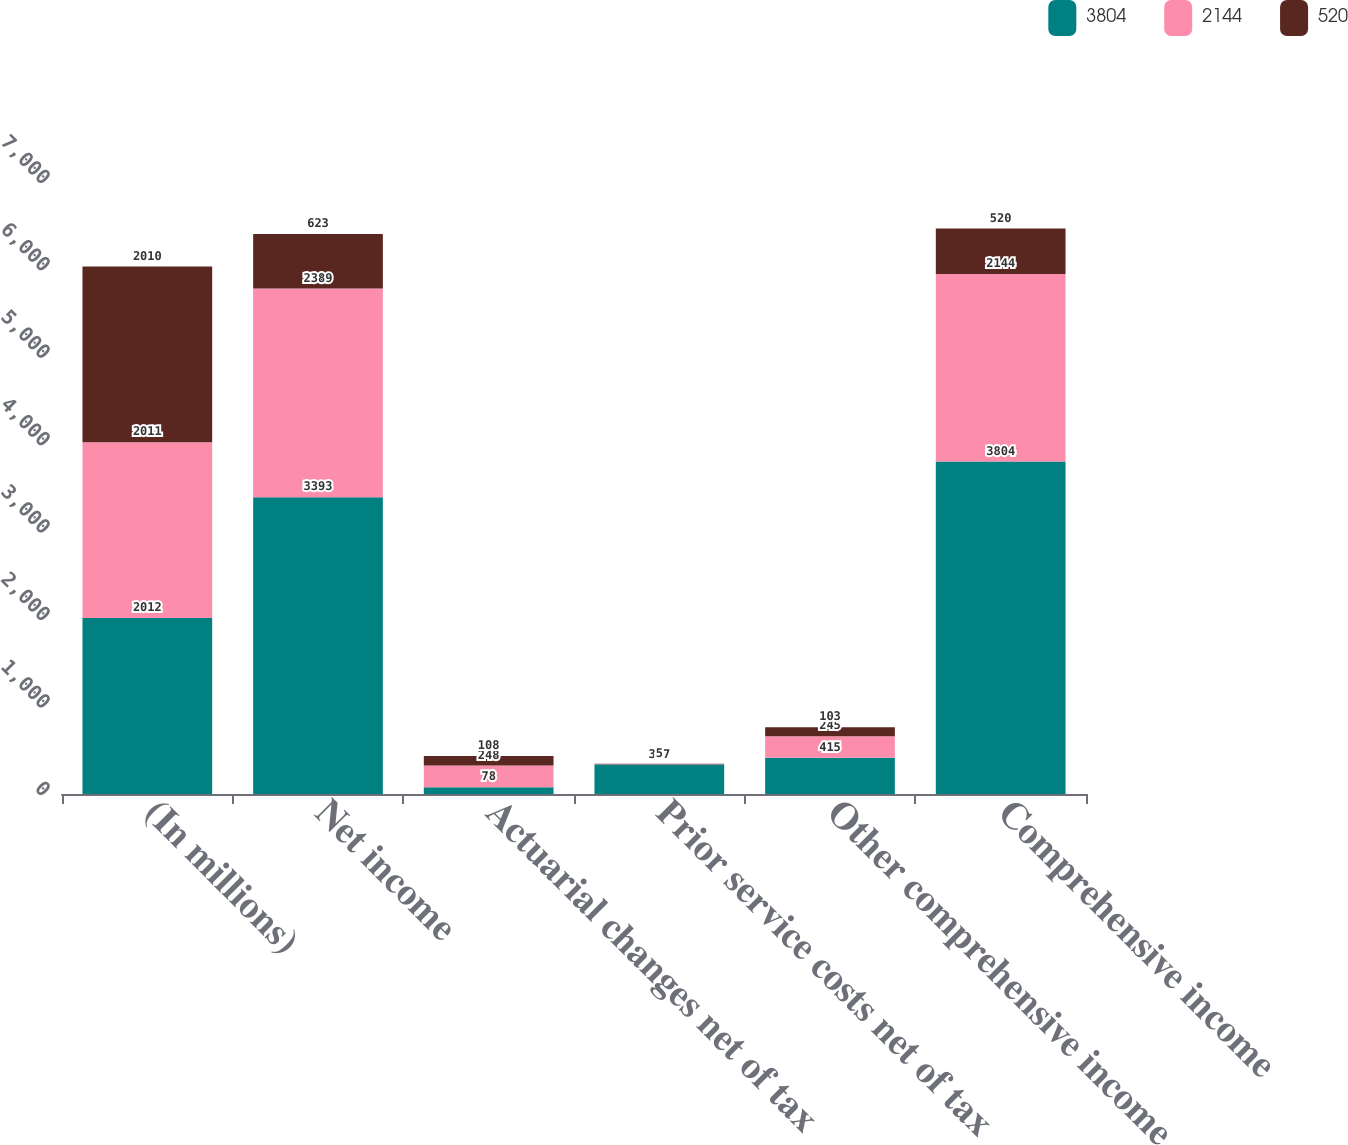Convert chart to OTSL. <chart><loc_0><loc_0><loc_500><loc_500><stacked_bar_chart><ecel><fcel>(In millions)<fcel>Net income<fcel>Actuarial changes net of tax<fcel>Prior service costs net of tax<fcel>Other comprehensive income<fcel>Comprehensive income<nl><fcel>3804<fcel>2012<fcel>3393<fcel>78<fcel>337<fcel>415<fcel>3804<nl><fcel>2144<fcel>2011<fcel>2389<fcel>248<fcel>4<fcel>245<fcel>2144<nl><fcel>520<fcel>2010<fcel>623<fcel>108<fcel>5<fcel>103<fcel>520<nl></chart> 